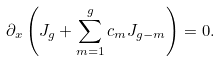Convert formula to latex. <formula><loc_0><loc_0><loc_500><loc_500>\partial _ { x } \left ( J _ { g } + \sum _ { m = 1 } ^ { g } c _ { m } J _ { g - m } \right ) = 0 .</formula> 